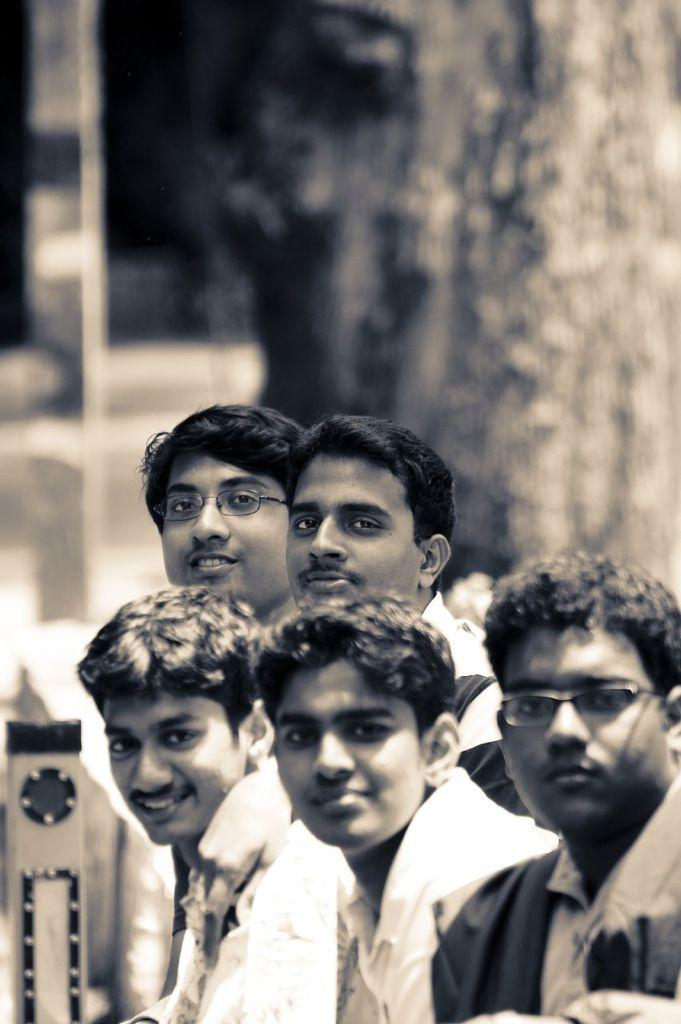What is the color scheme of the image? The image is black and white. How many men are present in the image? There are five men standing in the image. Can you describe any specific features of the men? Two of the men are wearing spectacles. What can be observed about the background of the image? There is a blurred background in the image. What type of fear is depicted in the image? There is no fear depicted in the image; it features five men standing in a black and white setting. How many giants can be seen in the image? There are no giants present in the image; it features five men of average height. 